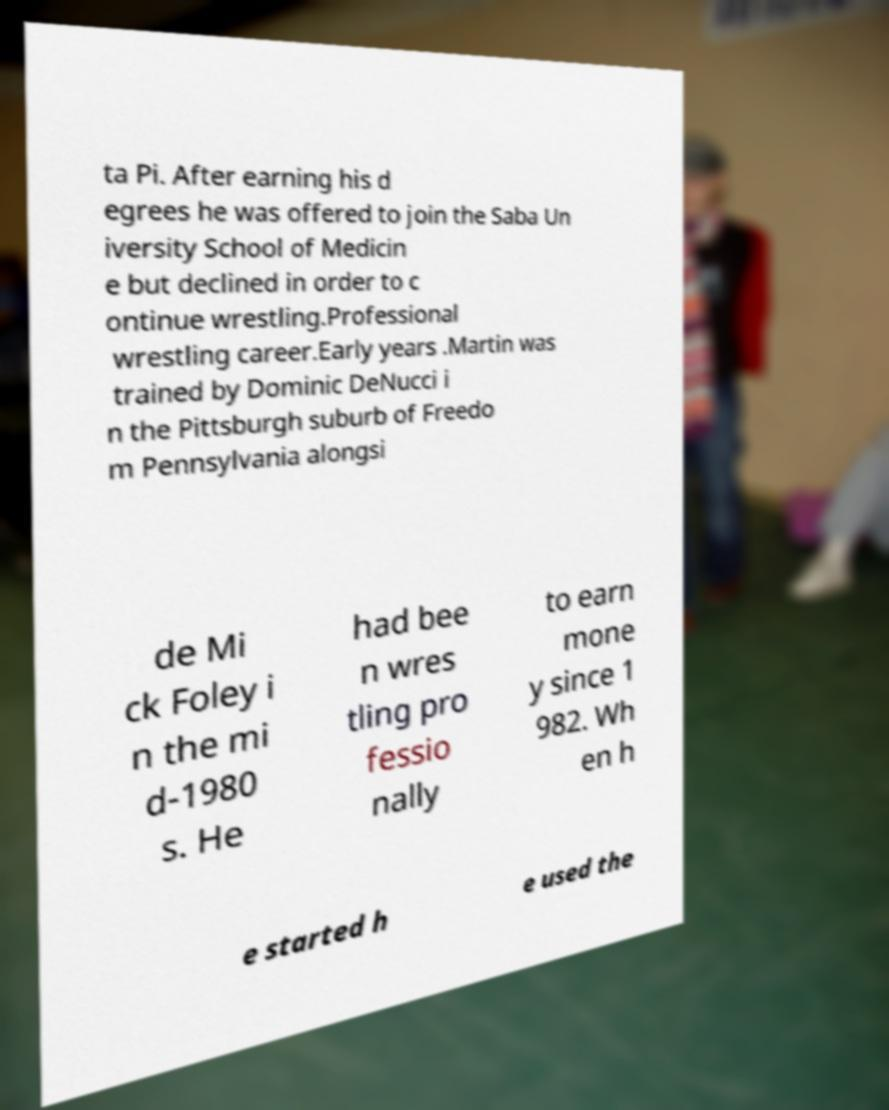Could you assist in decoding the text presented in this image and type it out clearly? ta Pi. After earning his d egrees he was offered to join the Saba Un iversity School of Medicin e but declined in order to c ontinue wrestling.Professional wrestling career.Early years .Martin was trained by Dominic DeNucci i n the Pittsburgh suburb of Freedo m Pennsylvania alongsi de Mi ck Foley i n the mi d-1980 s. He had bee n wres tling pro fessio nally to earn mone y since 1 982. Wh en h e started h e used the 